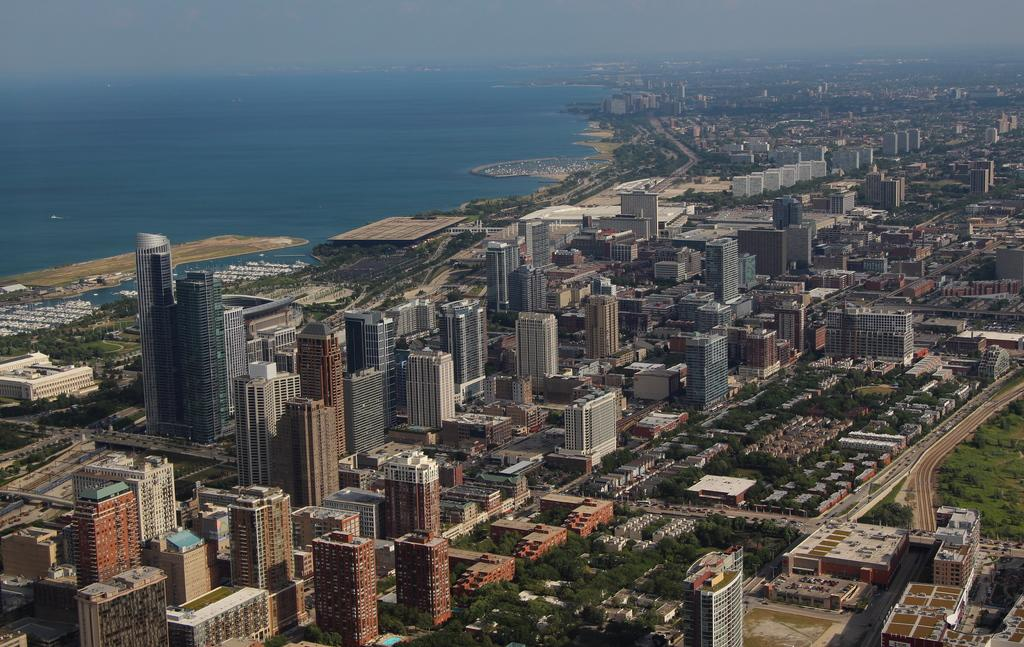What is the main subject of the image? The main subject of the image is an overview of a city. What types of structures can be seen in the image? There are buildings in the image. Are there any natural elements present in the image? Yes, there are trees in the image. What body of water is visible in the image? There is a surface of water visible in the image. What type of bell can be heard ringing in the image? There is no bell present in the image, and therefore no sound can be heard. Can you describe the feathers on the birds flying over the city in the image? There are no birds or feathers visible in the image. 